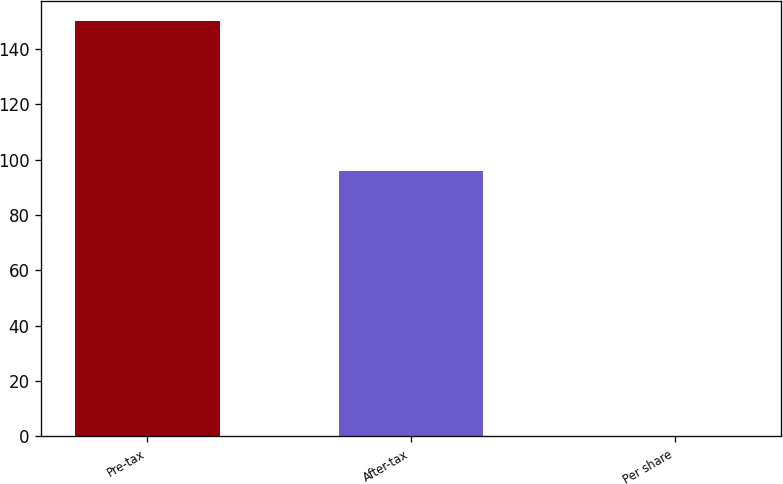Convert chart. <chart><loc_0><loc_0><loc_500><loc_500><bar_chart><fcel>Pre-tax<fcel>After-tax<fcel>Per share<nl><fcel>150<fcel>96<fcel>0.06<nl></chart> 